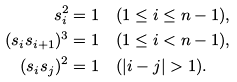<formula> <loc_0><loc_0><loc_500><loc_500>s _ { i } ^ { 2 } = 1 & \quad ( 1 \leq i \leq n - 1 ) , \\ ( s _ { i } s _ { i + 1 } ) ^ { 3 } = 1 & \quad ( 1 \leq i < n - 1 ) , \\ ( s _ { i } s _ { j } ) ^ { 2 } = 1 & \quad ( | i - j | > 1 ) .</formula> 